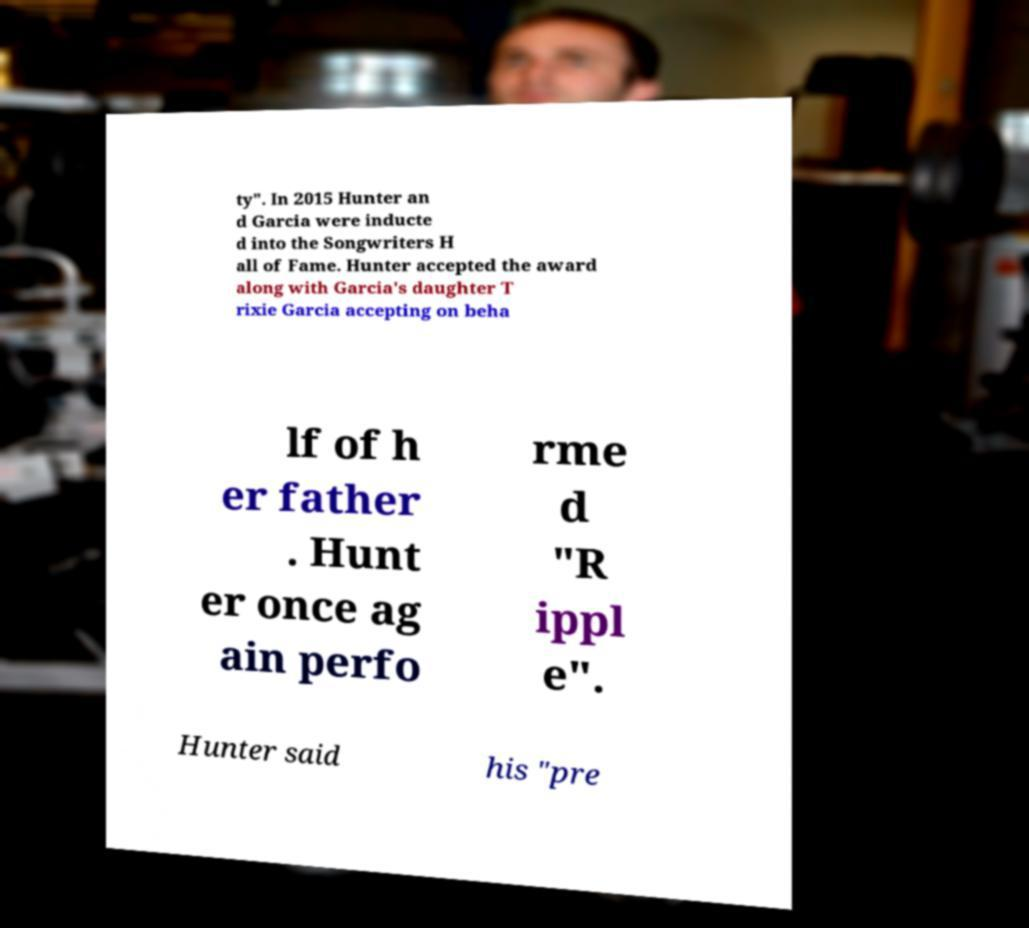Could you assist in decoding the text presented in this image and type it out clearly? ty". In 2015 Hunter an d Garcia were inducte d into the Songwriters H all of Fame. Hunter accepted the award along with Garcia's daughter T rixie Garcia accepting on beha lf of h er father . Hunt er once ag ain perfo rme d "R ippl e". Hunter said his "pre 